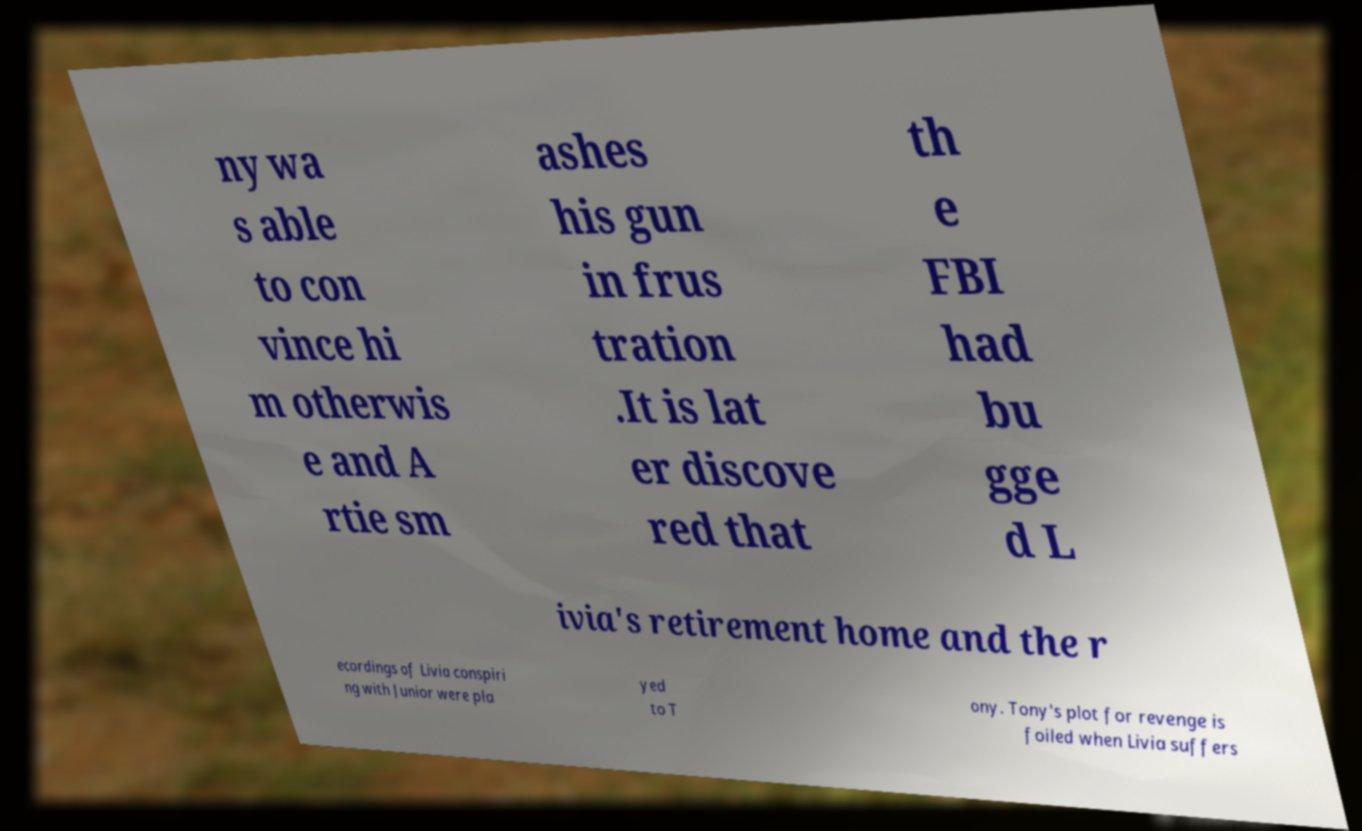Can you accurately transcribe the text from the provided image for me? ny wa s able to con vince hi m otherwis e and A rtie sm ashes his gun in frus tration .It is lat er discove red that th e FBI had bu gge d L ivia's retirement home and the r ecordings of Livia conspiri ng with Junior were pla yed to T ony. Tony's plot for revenge is foiled when Livia suffers 